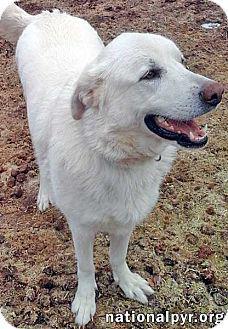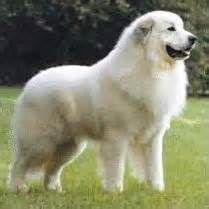The first image is the image on the left, the second image is the image on the right. Examine the images to the left and right. Is the description "An image includes a large white dog on the grass next to a sitting puppy with its nose raised to the adult dog's face." accurate? Answer yes or no. No. The first image is the image on the left, the second image is the image on the right. Considering the images on both sides, is "The right image contains exactly one white dog." valid? Answer yes or no. Yes. 